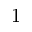Convert formula to latex. <formula><loc_0><loc_0><loc_500><loc_500>1</formula> 